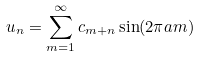Convert formula to latex. <formula><loc_0><loc_0><loc_500><loc_500>u _ { n } = \sum _ { m = 1 } ^ { \infty } c _ { m + n } \sin ( 2 \pi a m )</formula> 